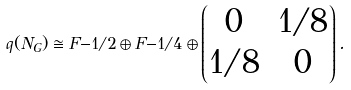<formula> <loc_0><loc_0><loc_500><loc_500>q ( N _ { G } ) \cong \L F { - 1 / 2 } \oplus \L F { - 1 / 4 } \oplus \begin{pmatrix} 0 & 1 / 8 \\ 1 / 8 & 0 \end{pmatrix} .</formula> 